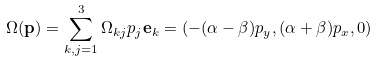Convert formula to latex. <formula><loc_0><loc_0><loc_500><loc_500>\Omega ( \mathbf p ) = \sum _ { k , j = 1 } ^ { 3 } \Omega _ { k j } p _ { j } \mathbf e _ { k } = ( - ( \alpha - \beta ) p _ { y } , ( \alpha + \beta ) p _ { x } , 0 )</formula> 